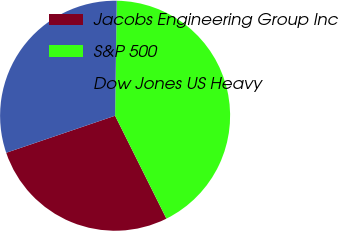Convert chart to OTSL. <chart><loc_0><loc_0><loc_500><loc_500><pie_chart><fcel>Jacobs Engineering Group Inc<fcel>S&P 500<fcel>Dow Jones US Heavy<nl><fcel>27.14%<fcel>42.41%<fcel>30.44%<nl></chart> 